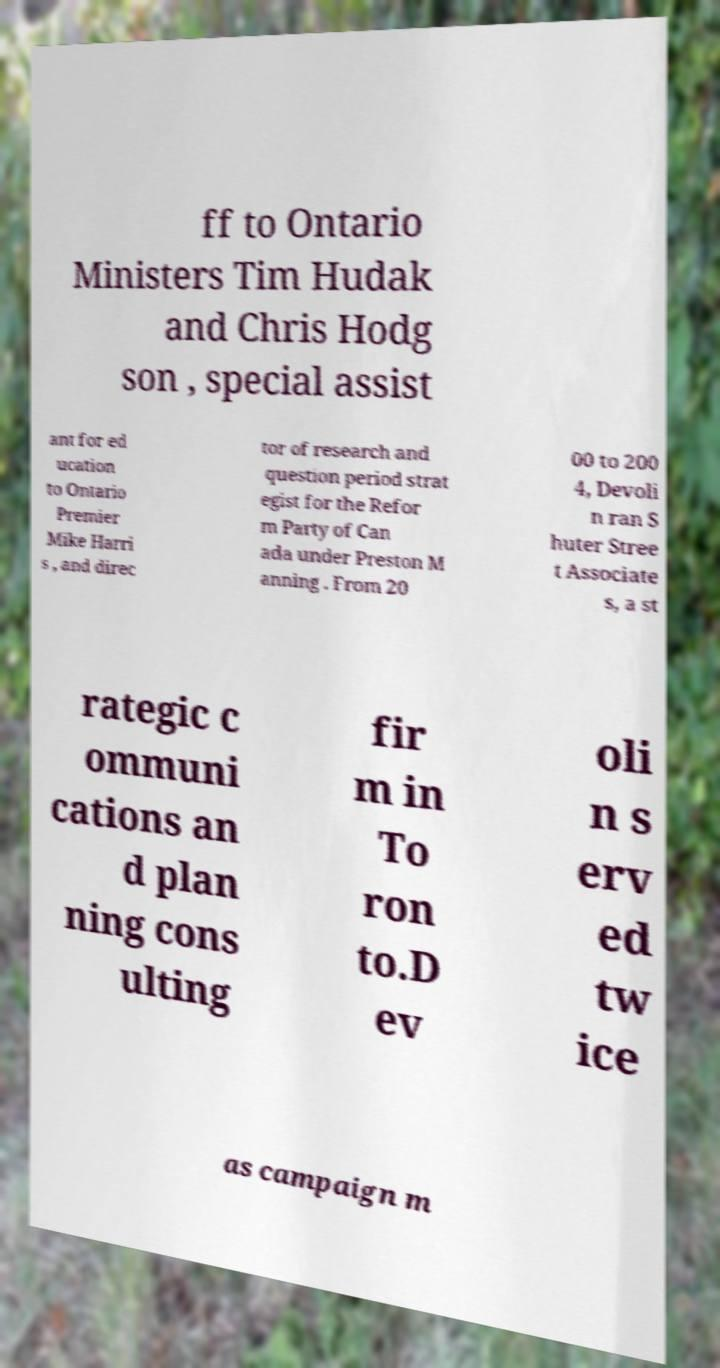Please read and relay the text visible in this image. What does it say? ff to Ontario Ministers Tim Hudak and Chris Hodg son , special assist ant for ed ucation to Ontario Premier Mike Harri s , and direc tor of research and question period strat egist for the Refor m Party of Can ada under Preston M anning . From 20 00 to 200 4, Devoli n ran S huter Stree t Associate s, a st rategic c ommuni cations an d plan ning cons ulting fir m in To ron to.D ev oli n s erv ed tw ice as campaign m 